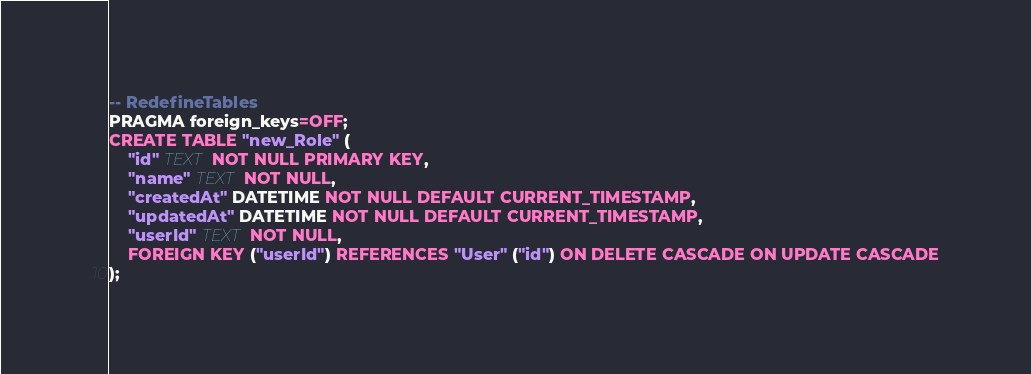Convert code to text. <code><loc_0><loc_0><loc_500><loc_500><_SQL_>-- RedefineTables
PRAGMA foreign_keys=OFF;
CREATE TABLE "new_Role" (
    "id" TEXT NOT NULL PRIMARY KEY,
    "name" TEXT NOT NULL,
    "createdAt" DATETIME NOT NULL DEFAULT CURRENT_TIMESTAMP,
    "updatedAt" DATETIME NOT NULL DEFAULT CURRENT_TIMESTAMP,
    "userId" TEXT NOT NULL,
    FOREIGN KEY ("userId") REFERENCES "User" ("id") ON DELETE CASCADE ON UPDATE CASCADE
);</code> 